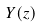Convert formula to latex. <formula><loc_0><loc_0><loc_500><loc_500>Y ( z )</formula> 